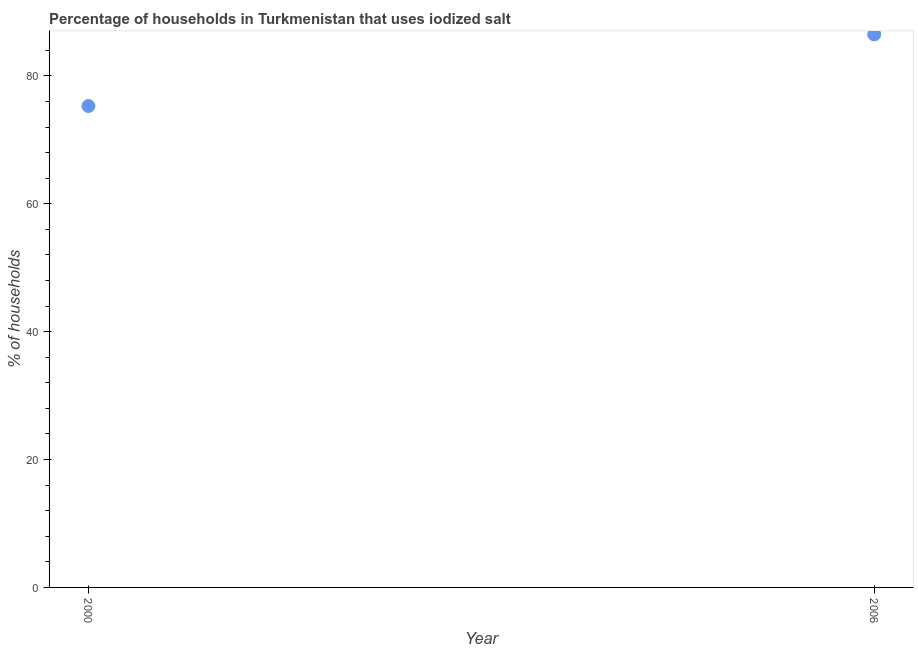What is the percentage of households where iodized salt is consumed in 2006?
Give a very brief answer. 86.5. Across all years, what is the maximum percentage of households where iodized salt is consumed?
Give a very brief answer. 86.5. Across all years, what is the minimum percentage of households where iodized salt is consumed?
Give a very brief answer. 75.3. What is the sum of the percentage of households where iodized salt is consumed?
Make the answer very short. 161.8. What is the difference between the percentage of households where iodized salt is consumed in 2000 and 2006?
Provide a short and direct response. -11.2. What is the average percentage of households where iodized salt is consumed per year?
Offer a very short reply. 80.9. What is the median percentage of households where iodized salt is consumed?
Your answer should be very brief. 80.9. What is the ratio of the percentage of households where iodized salt is consumed in 2000 to that in 2006?
Your answer should be compact. 0.87. In how many years, is the percentage of households where iodized salt is consumed greater than the average percentage of households where iodized salt is consumed taken over all years?
Your answer should be very brief. 1. How many dotlines are there?
Your answer should be compact. 1. How many years are there in the graph?
Provide a short and direct response. 2. Does the graph contain any zero values?
Your response must be concise. No. Does the graph contain grids?
Your answer should be very brief. No. What is the title of the graph?
Ensure brevity in your answer.  Percentage of households in Turkmenistan that uses iodized salt. What is the label or title of the X-axis?
Your answer should be very brief. Year. What is the label or title of the Y-axis?
Provide a succinct answer. % of households. What is the % of households in 2000?
Provide a succinct answer. 75.3. What is the % of households in 2006?
Give a very brief answer. 86.5. What is the difference between the % of households in 2000 and 2006?
Make the answer very short. -11.2. What is the ratio of the % of households in 2000 to that in 2006?
Your response must be concise. 0.87. 